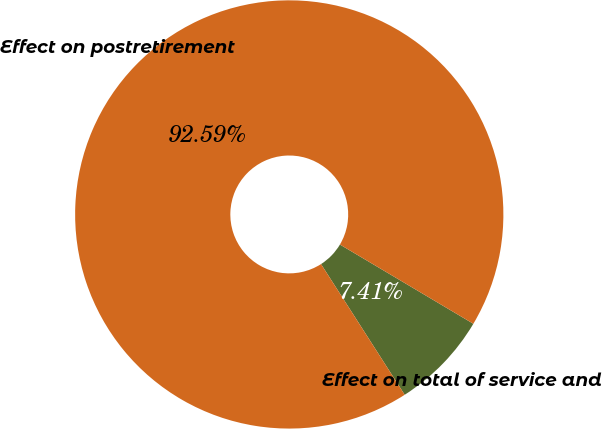Convert chart. <chart><loc_0><loc_0><loc_500><loc_500><pie_chart><fcel>Effect on total of service and<fcel>Effect on postretirement<nl><fcel>7.41%<fcel>92.59%<nl></chart> 